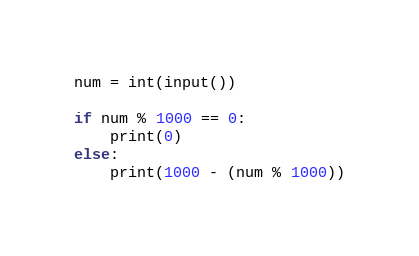Convert code to text. <code><loc_0><loc_0><loc_500><loc_500><_Python_>num = int(input())

if num % 1000 == 0:
    print(0)
else:
    print(1000 - (num % 1000))
</code> 